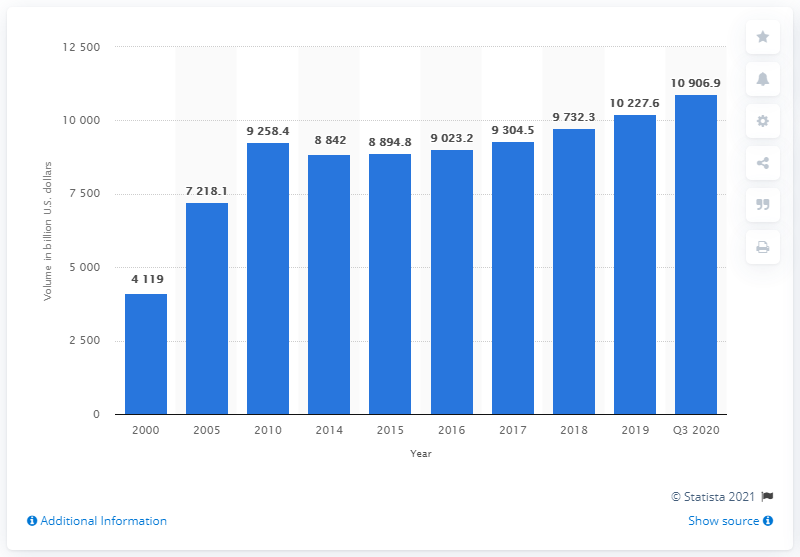Draw attention to some important aspects in this diagram. As of the third quarter of 2020, the volume of mortgage-backed securities outstanding in the United States was 10906.9... The average from 2018 to 2020 is 10,288.9. Mortgage-backed securities were last outstanding in the United States in the year 2000. In 2005, the volume was 7,218.1... 